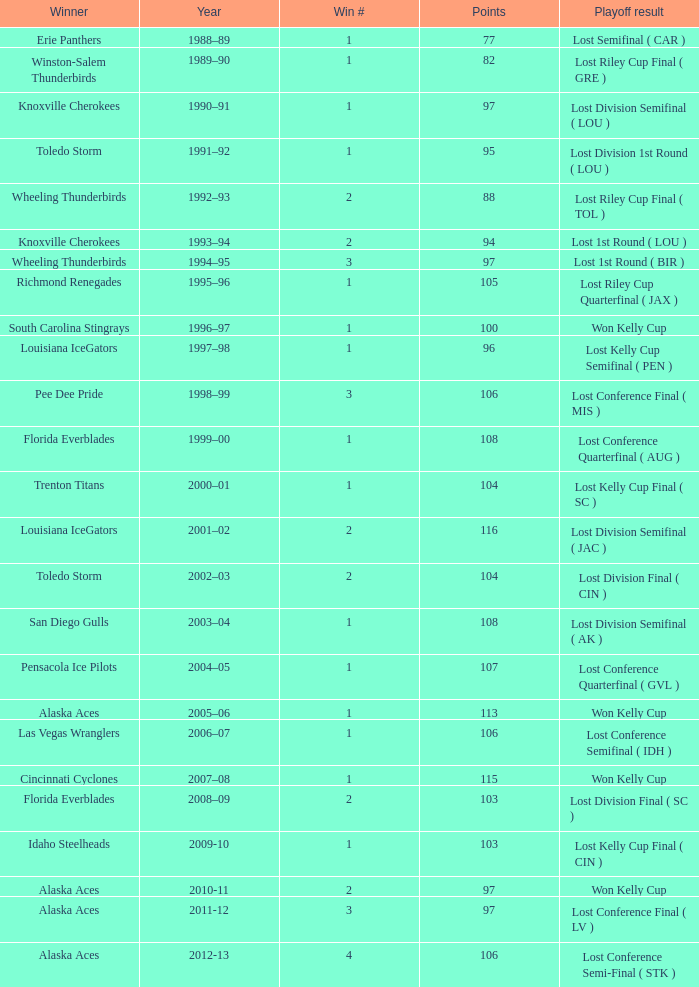What is Winner, when Win # is greater than 1, and when Points is less than 94? Wheeling Thunderbirds. 